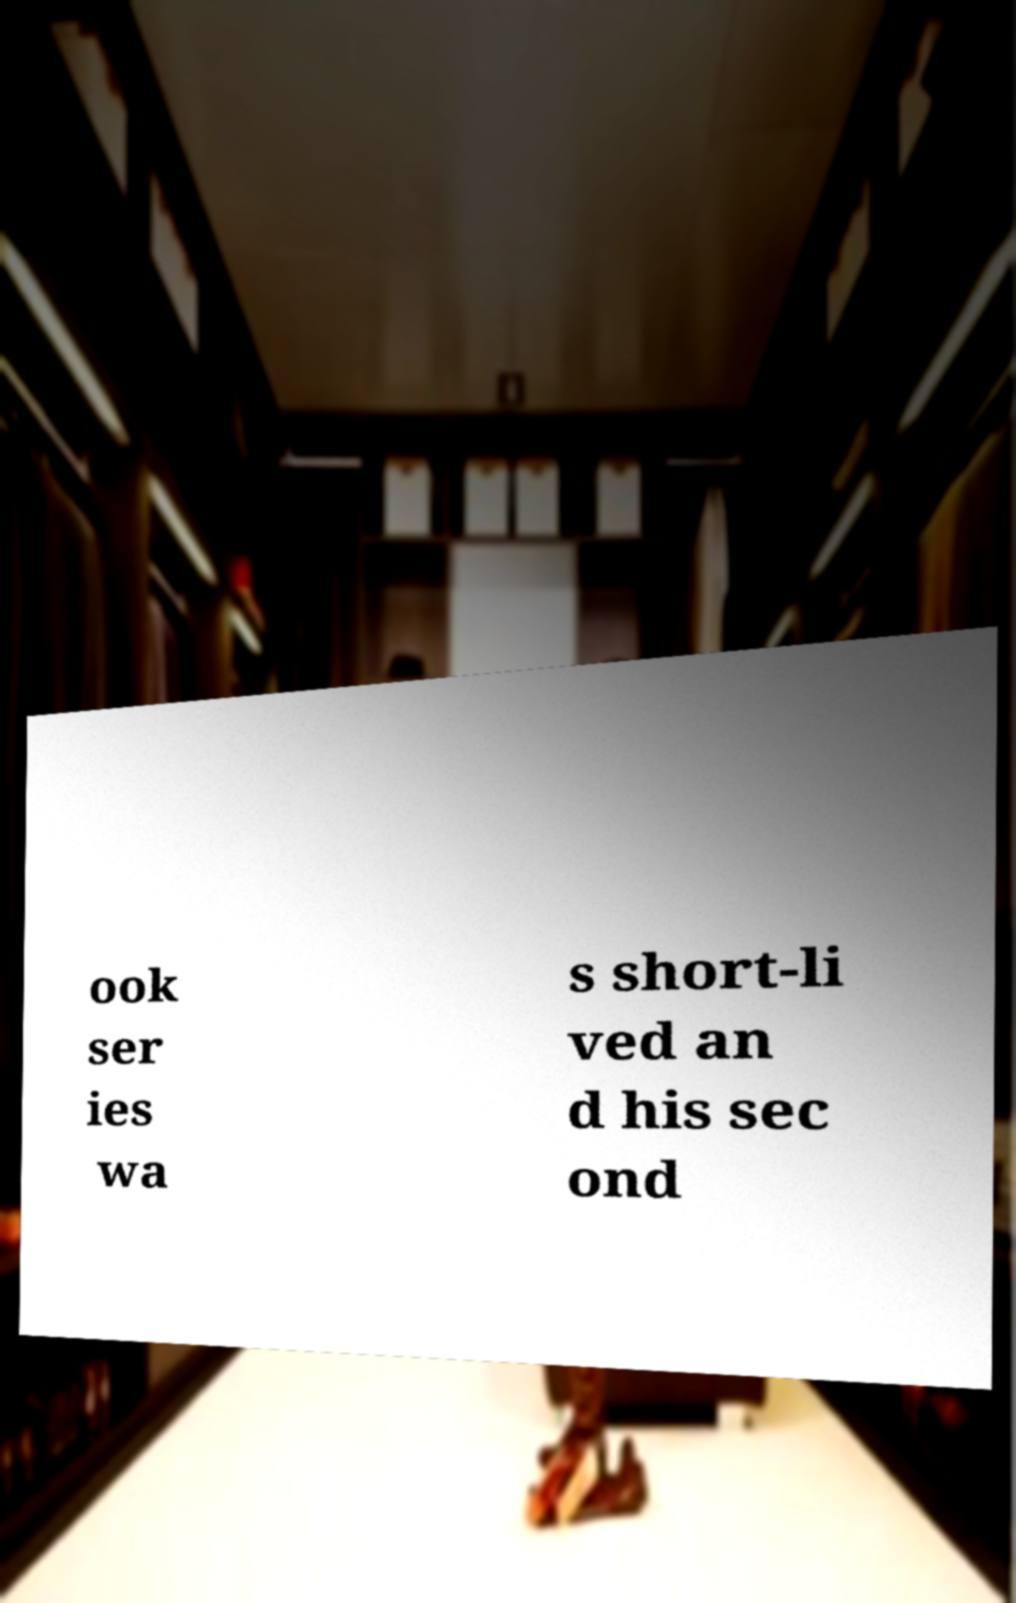What messages or text are displayed in this image? I need them in a readable, typed format. ook ser ies wa s short-li ved an d his sec ond 